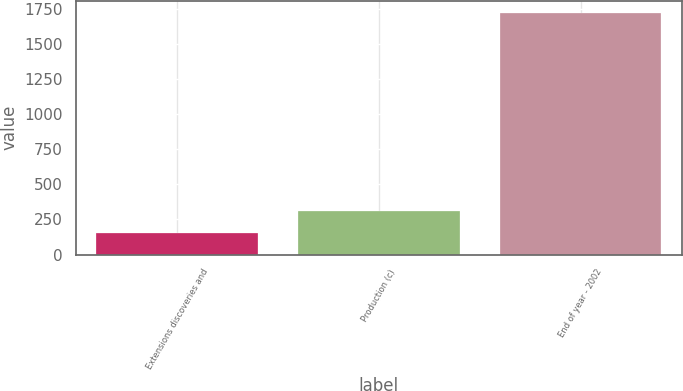<chart> <loc_0><loc_0><loc_500><loc_500><bar_chart><fcel>Extensions discoveries and<fcel>Production (c)<fcel>End of year - 2002<nl><fcel>156<fcel>312.8<fcel>1724<nl></chart> 